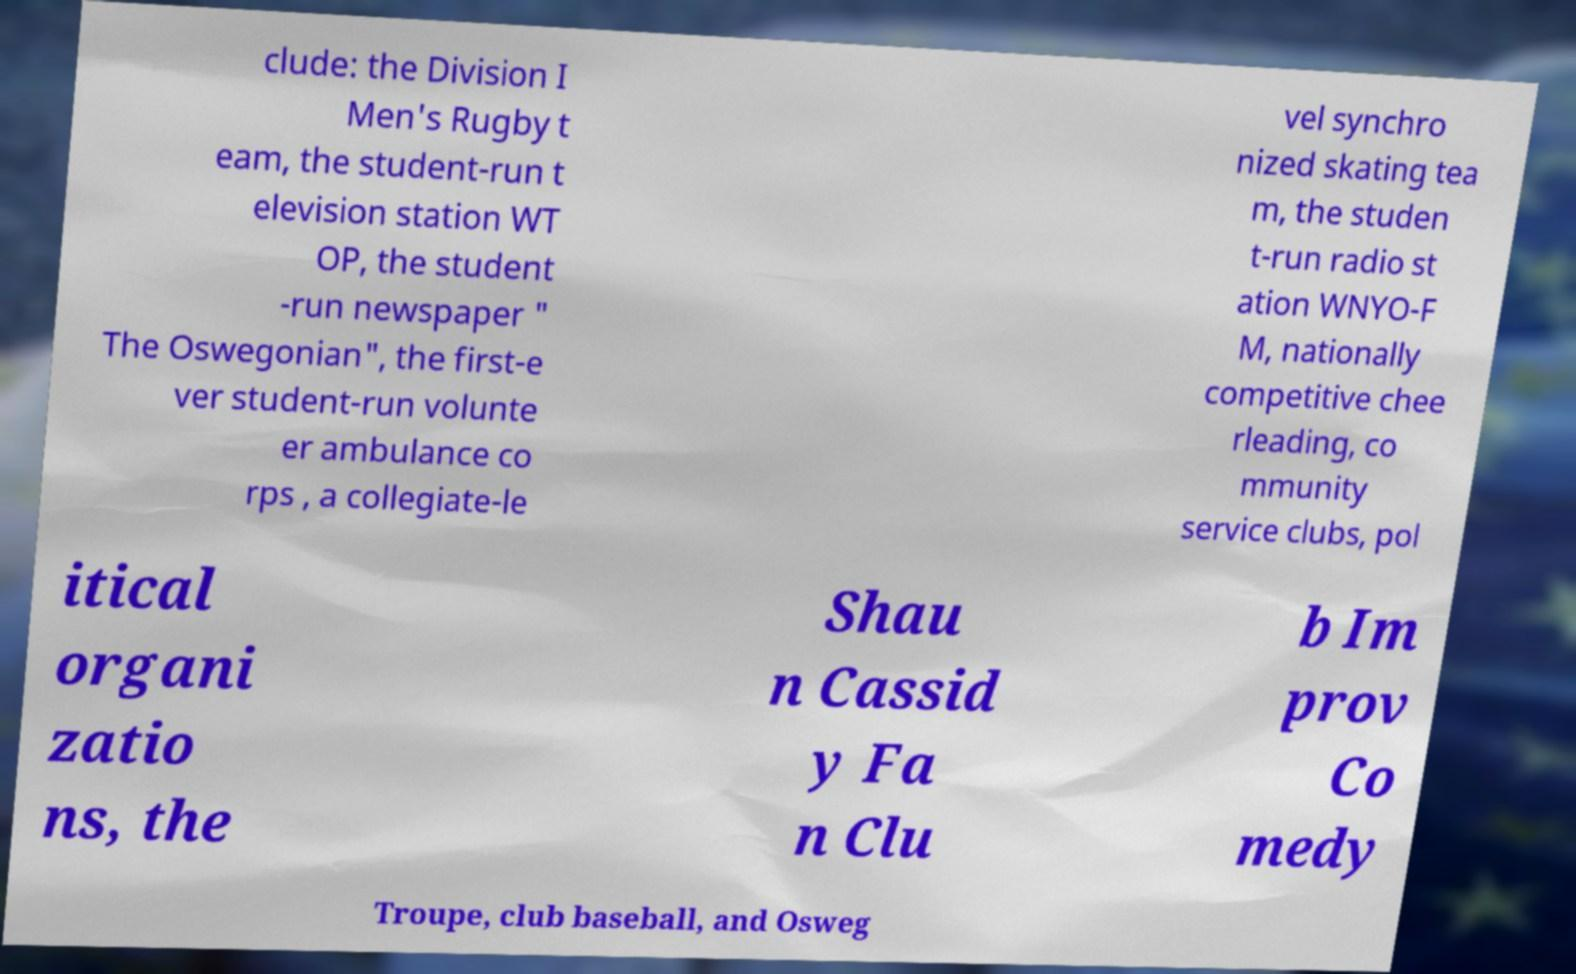Could you extract and type out the text from this image? clude: the Division I Men's Rugby t eam, the student-run t elevision station WT OP, the student -run newspaper " The Oswegonian", the first-e ver student-run volunte er ambulance co rps , a collegiate-le vel synchro nized skating tea m, the studen t-run radio st ation WNYO-F M, nationally competitive chee rleading, co mmunity service clubs, pol itical organi zatio ns, the Shau n Cassid y Fa n Clu b Im prov Co medy Troupe, club baseball, and Osweg 